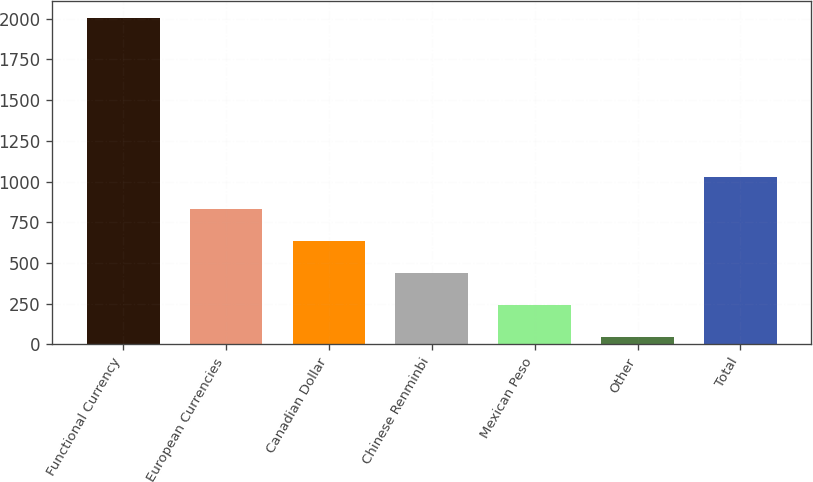Convert chart to OTSL. <chart><loc_0><loc_0><loc_500><loc_500><bar_chart><fcel>Functional Currency<fcel>European Currencies<fcel>Canadian Dollar<fcel>Chinese Renminbi<fcel>Mexican Peso<fcel>Other<fcel>Total<nl><fcel>2008<fcel>829.9<fcel>633.55<fcel>437.2<fcel>240.85<fcel>44.5<fcel>1026.25<nl></chart> 